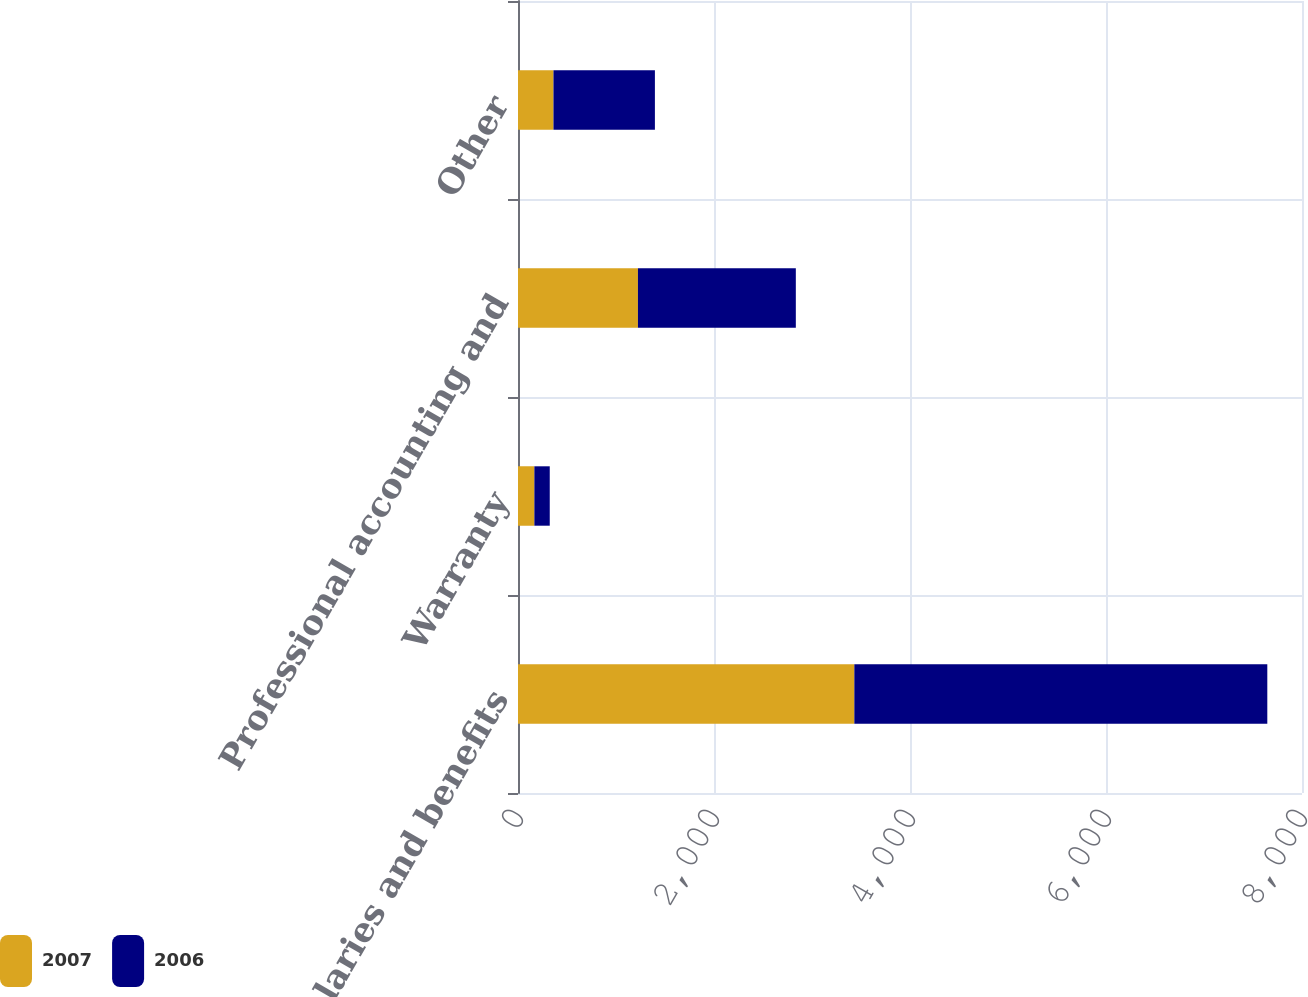Convert chart. <chart><loc_0><loc_0><loc_500><loc_500><stacked_bar_chart><ecel><fcel>Salaries and benefits<fcel>Warranty<fcel>Professional accounting and<fcel>Other<nl><fcel>2007<fcel>3432<fcel>167<fcel>1224<fcel>362<nl><fcel>2006<fcel>4214<fcel>157<fcel>1611<fcel>1035<nl></chart> 